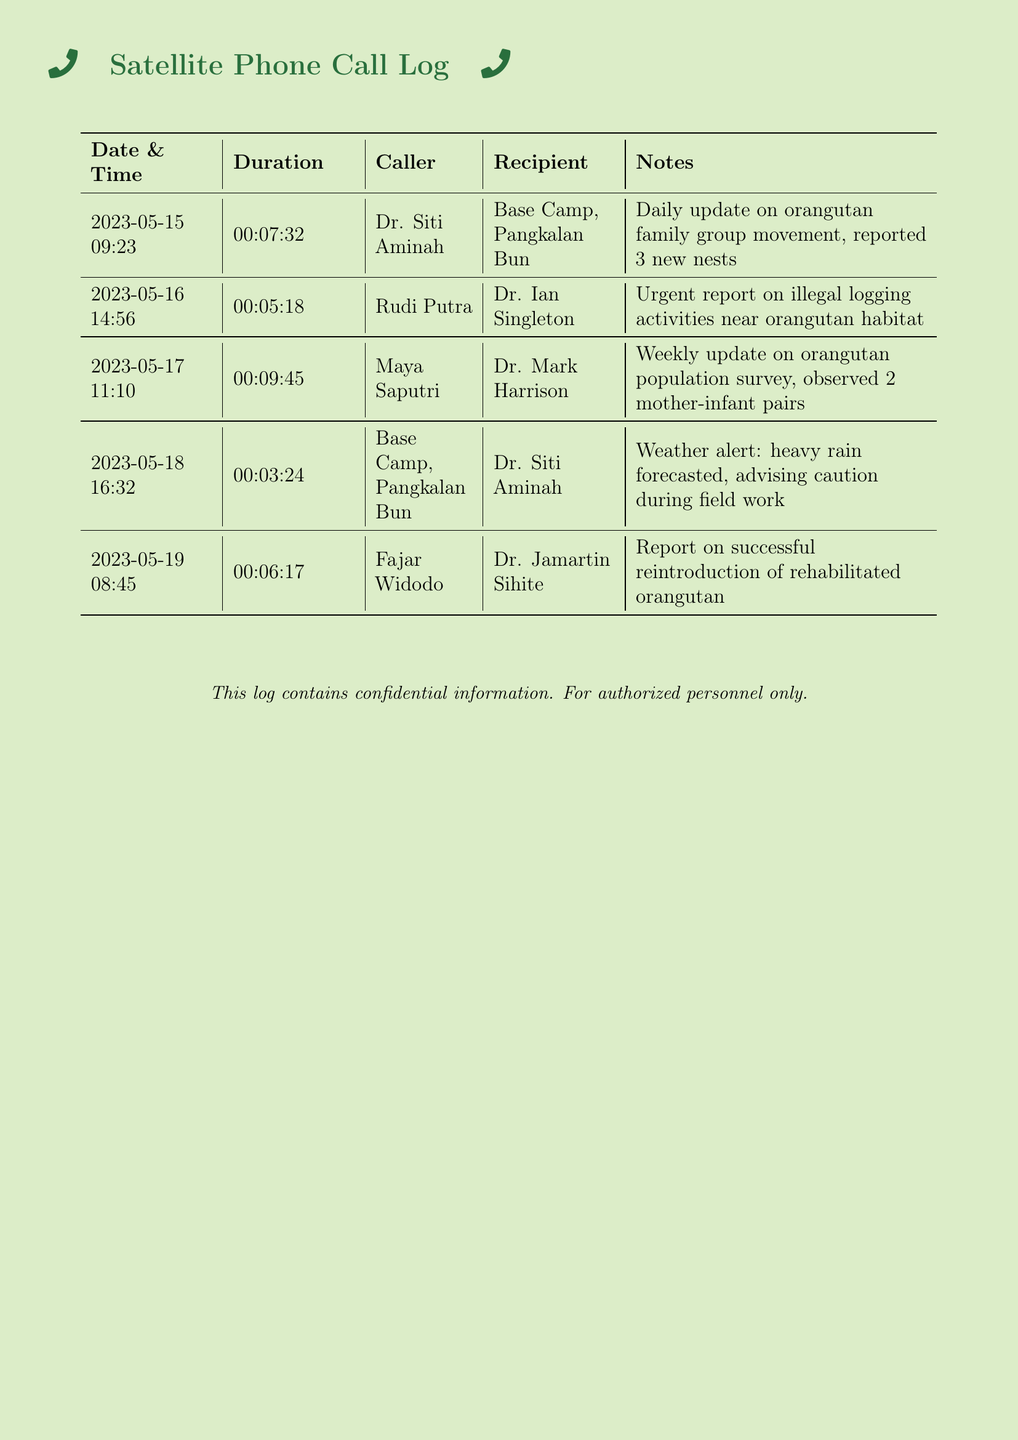What is the date of the first call? The first call in the log is dated May 15, 2023.
Answer: May 15, 2023 Who called Dr. Ian Singleton on May 16? The log indicates that Rudi Putra was the caller to Dr. Ian Singleton.
Answer: Rudi Putra How long did the call between Fajar Widodo and Dr. Jamartin Sihite last? The duration of the call is recorded as 6 minutes and 17 seconds.
Answer: 00:06:17 What was reported during the call with Dr. Mark Harrison? Maya Saputri reported the weekly update on orangutan population survey, specifically observing 2 mother-infant pairs.
Answer: 2 mother-infant pairs How many urgent reports are logged in this document? There is 1 urgent report regarding illegal logging activities noted in the log.
Answer: 1 What kind of event did Base Camp warn about on May 18? The call notes mention a heavy rain forecast advising caution during field work.
Answer: heavy rain Which call had the longest duration? The longest call duration is 9 minutes and 45 seconds between Maya Saputri and Dr. Mark Harrison.
Answer: 00:09:45 What is the purpose of the call log? The purpose of the call log is to record satellite phone communications related to orangutan tracking and updates.
Answer: communication Who was the recipient of the call from Base Camp on May 18? The recipient of the call from Base Camp is Dr. Siti Aminah.
Answer: Dr. Siti Aminah What type of communication does this document log? This document logs satellite phone communications.
Answer: satellite phone communications 